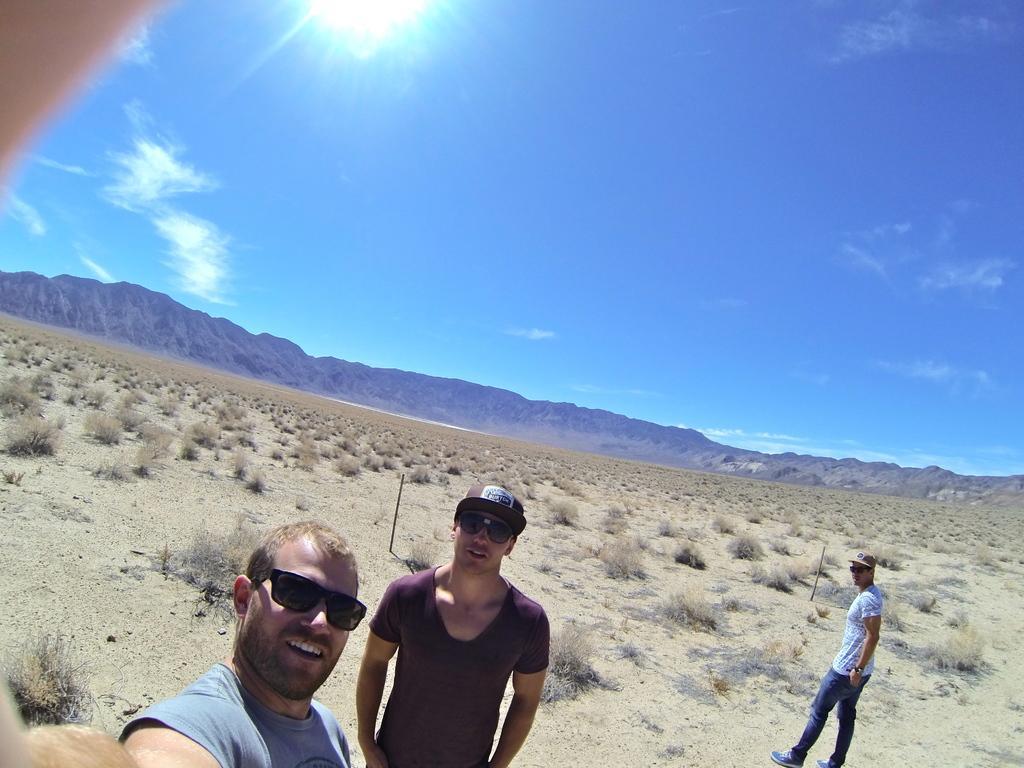Could you give a brief overview of what you see in this image? In this image there are two people in the foreground and they are wearing spectacles. There is a person on the right corner. There is a ground at the bottom. There are mountains in the background. And there is sky at the top. 